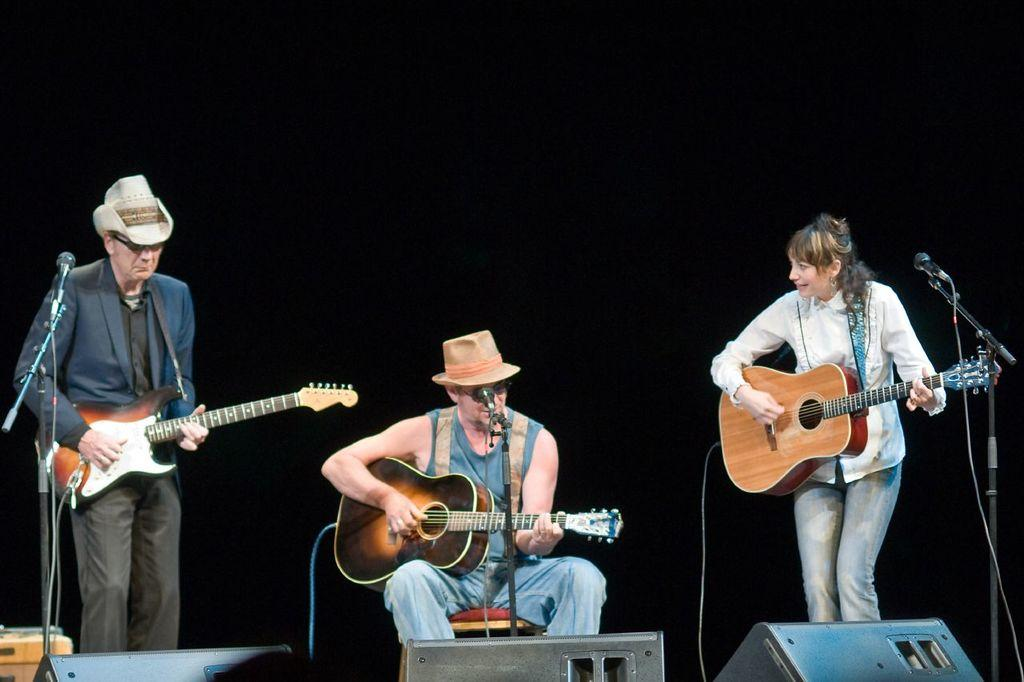How many people are in the image? There are three people in the image. What are the people doing in the image? The people are playing guitars. What equipment is set up in front of the people? A microphone and speakers (sound boxes) are placed in front of them. What event is the image from? The image is from a musical concert. What type of coal is being used to fuel the performance in the image? There is no coal present in the image, and coal is not used to fuel musical performances. 